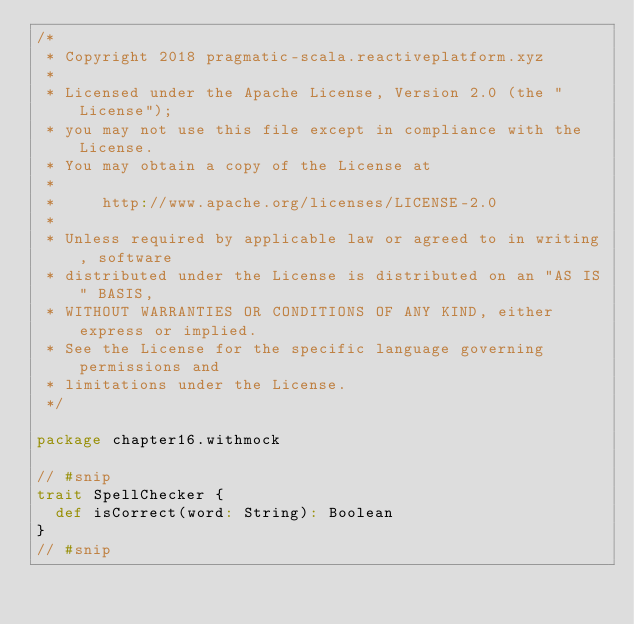<code> <loc_0><loc_0><loc_500><loc_500><_Scala_>/*
 * Copyright 2018 pragmatic-scala.reactiveplatform.xyz
 *
 * Licensed under the Apache License, Version 2.0 (the "License");
 * you may not use this file except in compliance with the License.
 * You may obtain a copy of the License at
 *
 *     http://www.apache.org/licenses/LICENSE-2.0
 *
 * Unless required by applicable law or agreed to in writing, software
 * distributed under the License is distributed on an "AS IS" BASIS,
 * WITHOUT WARRANTIES OR CONDITIONS OF ANY KIND, either express or implied.
 * See the License for the specific language governing permissions and
 * limitations under the License.
 */

package chapter16.withmock

// #snip
trait SpellChecker {
  def isCorrect(word: String): Boolean
}
// #snip
</code> 